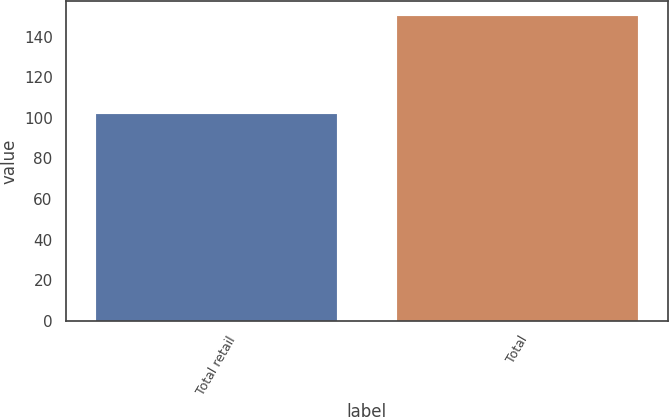Convert chart to OTSL. <chart><loc_0><loc_0><loc_500><loc_500><bar_chart><fcel>Total retail<fcel>Total<nl><fcel>102<fcel>150<nl></chart> 